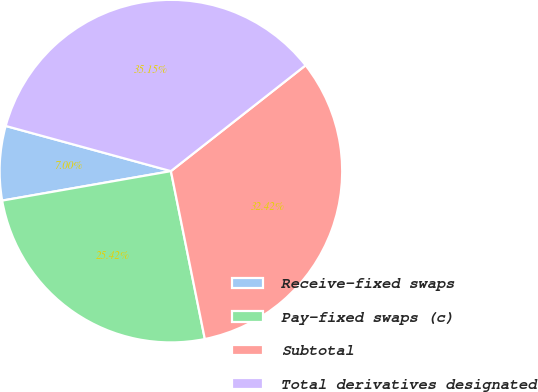Convert chart. <chart><loc_0><loc_0><loc_500><loc_500><pie_chart><fcel>Receive-fixed swaps<fcel>Pay-fixed swaps (c)<fcel>Subtotal<fcel>Total derivatives designated<nl><fcel>7.0%<fcel>25.42%<fcel>32.42%<fcel>35.15%<nl></chart> 